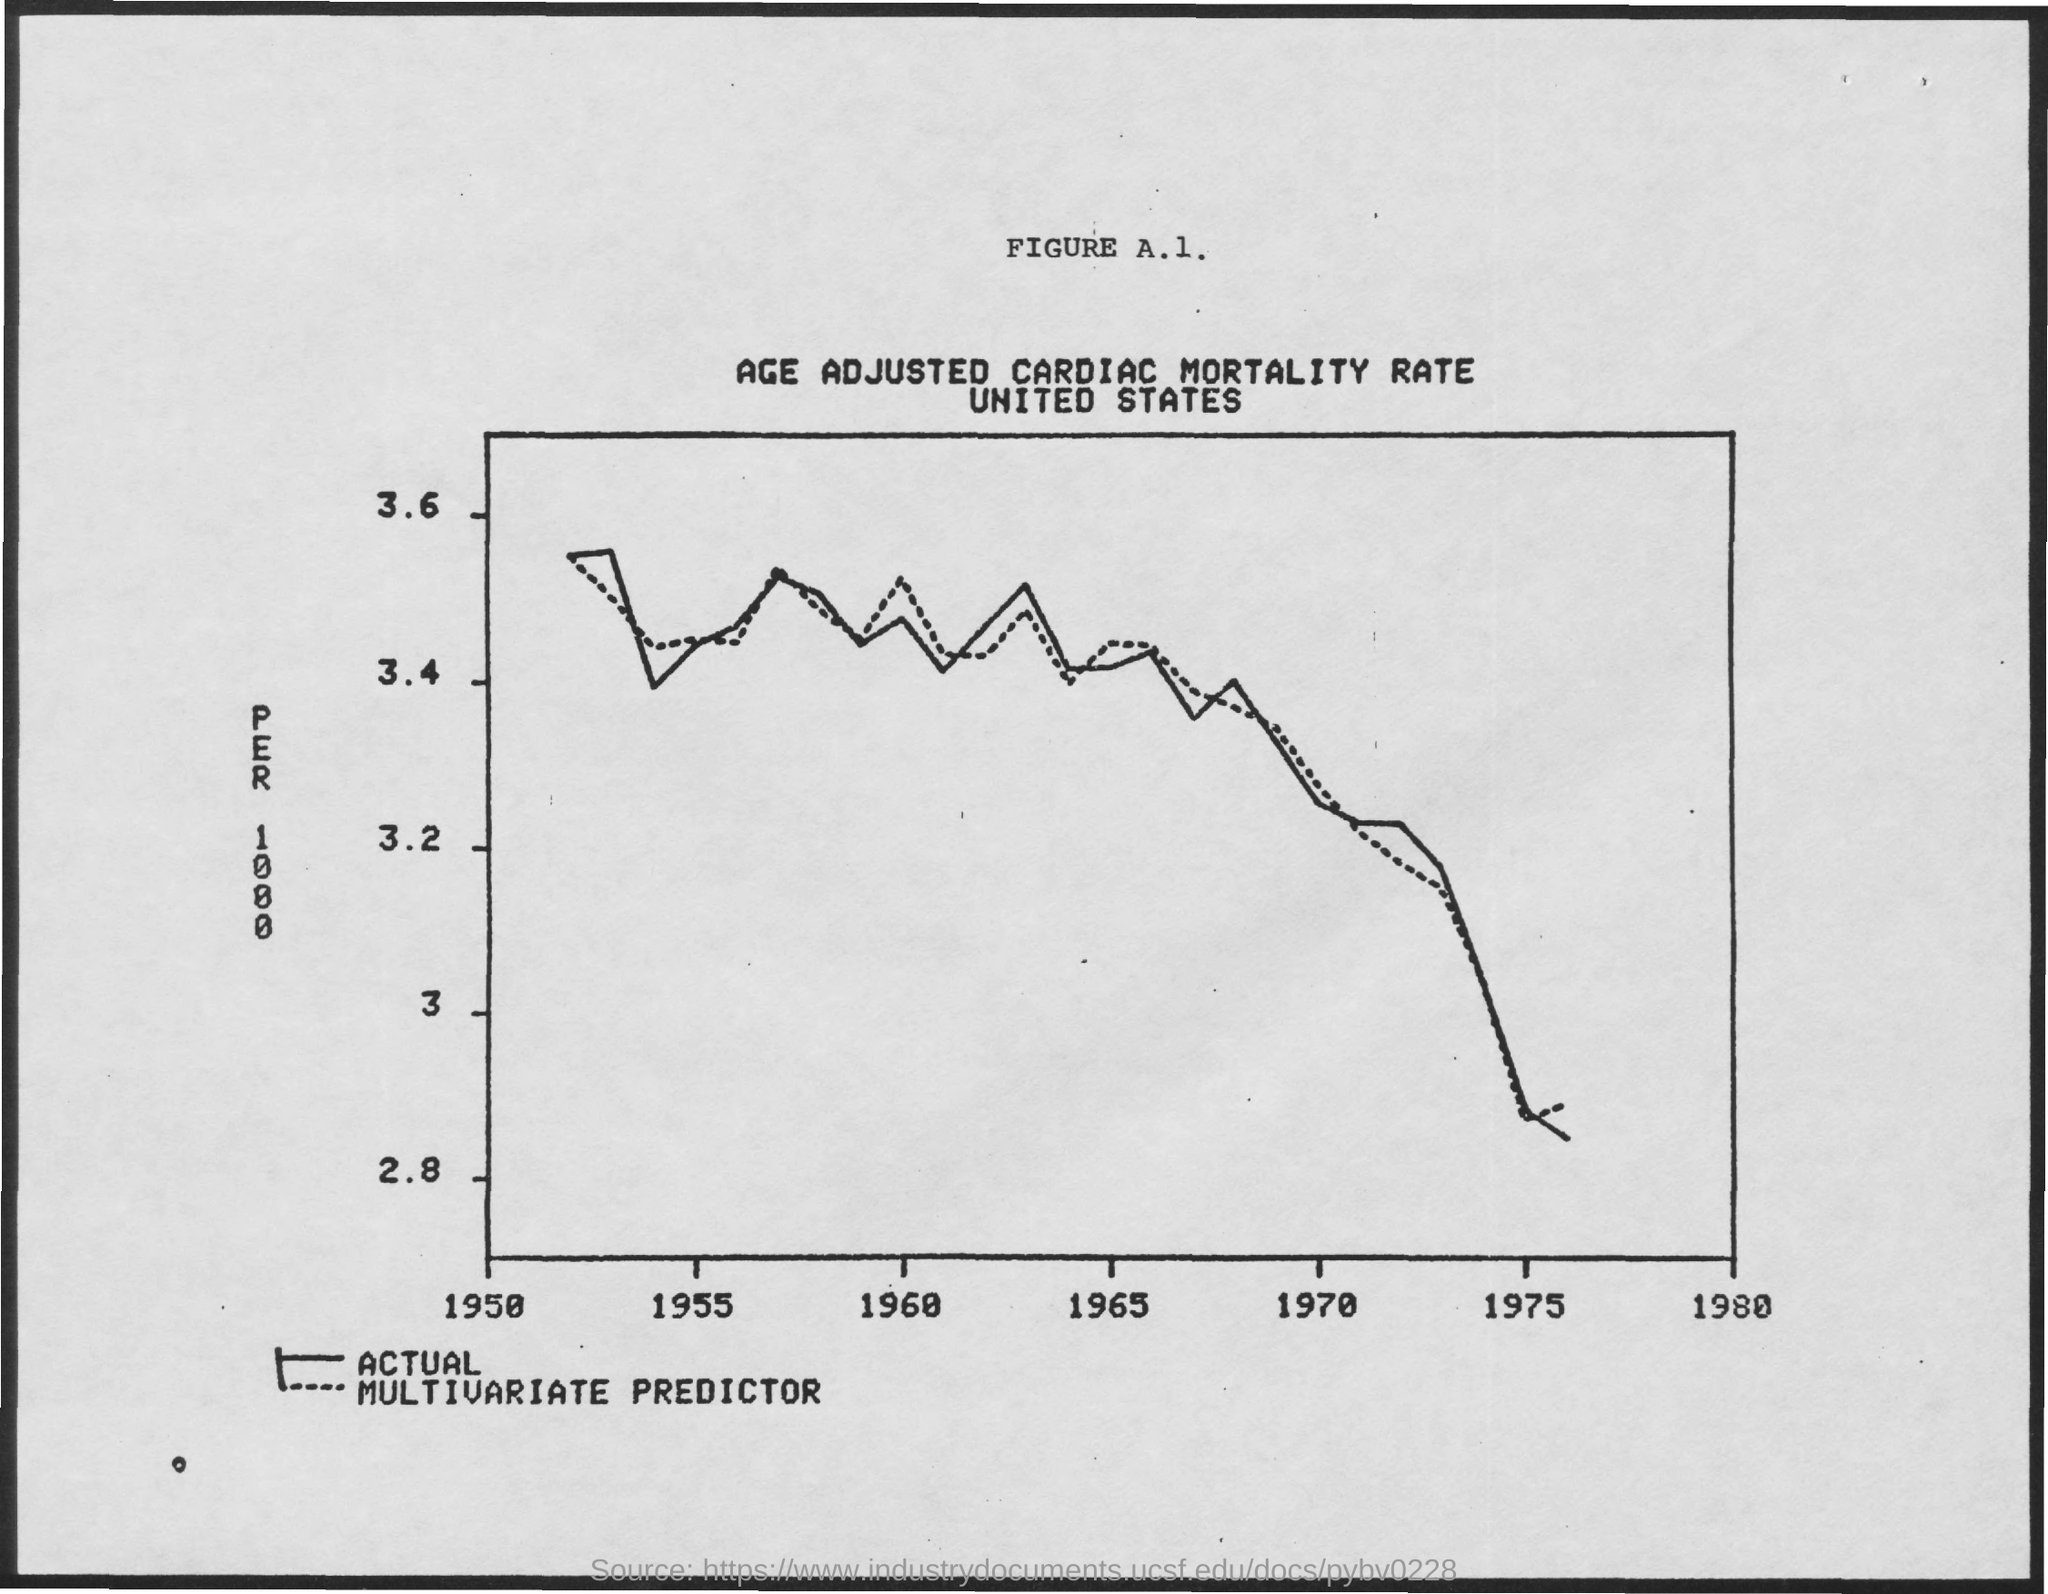Indicate a few pertinent items in this graphic. The title of Figure A.1 is "Age-adjusted Cardiac Mortality Rate. 